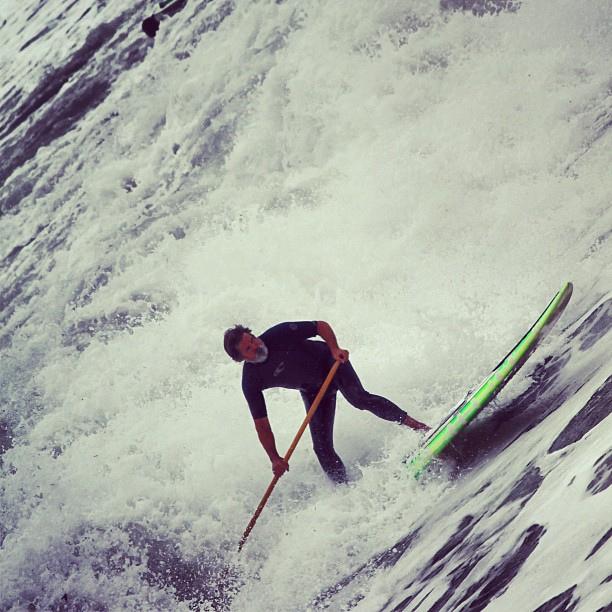Is this person wearing a wetsuit?
Write a very short answer. Yes. Does the person have a beard?
Keep it brief. Yes. Is this person a female?
Quick response, please. No. 